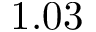<formula> <loc_0><loc_0><loc_500><loc_500>1 . 0 3</formula> 